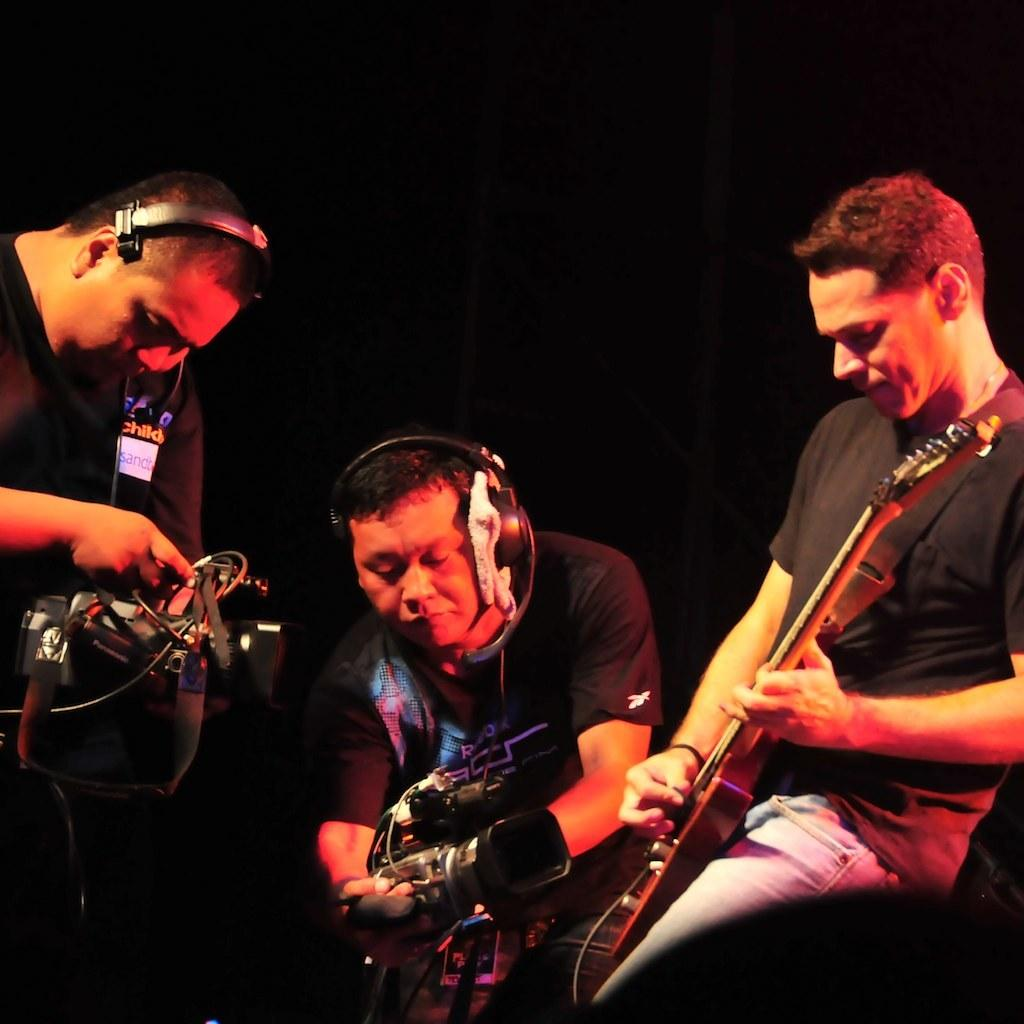How many people are in the image? There are three persons in the image. What are two of the persons wearing? Two of the persons are wearing headsets. What are the two persons with headsets holding? The two persons with headsets are holding video recorders. What is the third person doing in the image? One person is playing a guitar. What is the color of the background in the image? The background of the image is dark. What type of feast is being prepared by the persons in the image? There is no indication of a feast or any food preparation in the image. What is the size of the guitar being played by the third person? The size of the guitar cannot be determined from the image alone, as it is a two-dimensional representation. 